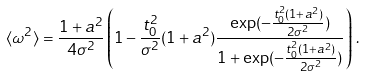Convert formula to latex. <formula><loc_0><loc_0><loc_500><loc_500>\langle \omega ^ { 2 } \rangle = \frac { 1 + a ^ { 2 } } { 4 \sigma ^ { 2 } } \left ( 1 - \frac { t _ { 0 } ^ { 2 } } { \sigma ^ { 2 } } ( 1 + a ^ { 2 } ) \frac { \exp ( - \frac { t _ { 0 } ^ { 2 } ( 1 + a ^ { 2 } ) } { 2 \sigma ^ { 2 } } ) } { 1 + \exp ( - \frac { t _ { 0 } ^ { 2 } ( 1 + a ^ { 2 } ) } { 2 \sigma ^ { 2 } } ) } \right ) \, .</formula> 